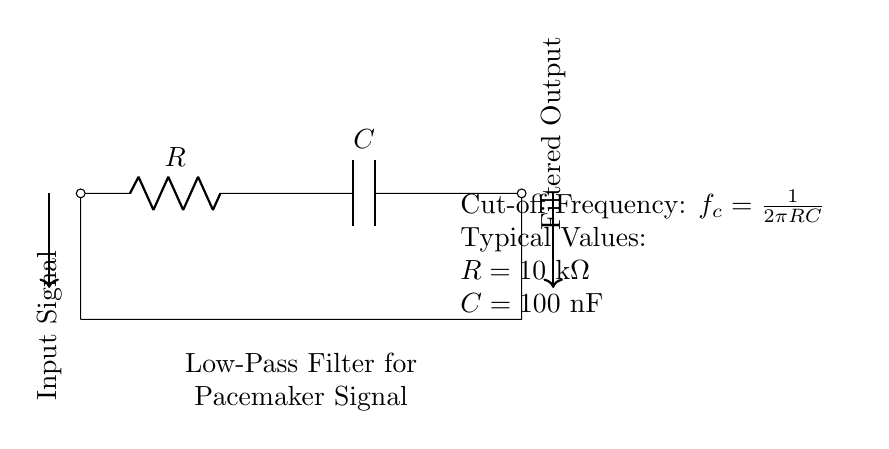What components are present in the circuit? The circuit consists of a resistor and a capacitor. These components are essential for the low-pass filter functionality, with the resistor connected in series and the capacitor connected in parallel after it.
Answer: Resistor, capacitor What is the role of the resistor in this circuit? The resistor limits the current flow in the circuit, controlling the charge time of the capacitor and thus affecting the cut-off frequency of the low-pass filter.
Answer: Current limiting What is the cut-off frequency formula? The cut-off frequency is defined as fc = 1/(2πRC). This formula shows how the cut-off frequency is inversely related to both the resistance and capacitance values.
Answer: fc = 1/(2πRC) What are the typical values for resistance and capacitance in this circuit? The typical values given are R equals ten kilohms and C equals one hundred nanofarads. These specific values help in designing the desired filter characteristics for pacemaker signals.
Answer: R = 10 kΩ, C = 100 nF How does this low-pass filter affect pacemaker signals? The low-pass filter allows signals below a certain frequency to pass through while attenuating (reducing) the higher-frequency noise. This is crucial for maintaining signal integrity in pacemaker function.
Answer: Reduces noise What is the output of this low-pass filter when exposed to noise? The output will be a filtered signal with reduced noise, meaning higher frequency components will be significantly attenuated compared to the original input.
Answer: Filtered output How does changing the resistance influence the cut-off frequency? Increasing the resistance will decrease the cut-off frequency, allowing lower frequencies to pass and attenuating higher frequency, whereas decreasing resistance will do the opposite. This alters the filter's response to the signal frequencies.
Answer: Decreases cut-off frequency 